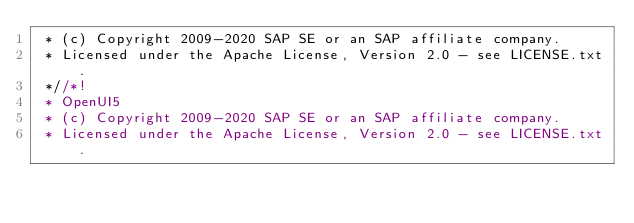Convert code to text. <code><loc_0><loc_0><loc_500><loc_500><_CSS_> * (c) Copyright 2009-2020 SAP SE or an SAP affiliate company.
 * Licensed under the Apache License, Version 2.0 - see LICENSE.txt.
 *//*!
 * OpenUI5
 * (c) Copyright 2009-2020 SAP SE or an SAP affiliate company.
 * Licensed under the Apache License, Version 2.0 - see LICENSE.txt.</code> 